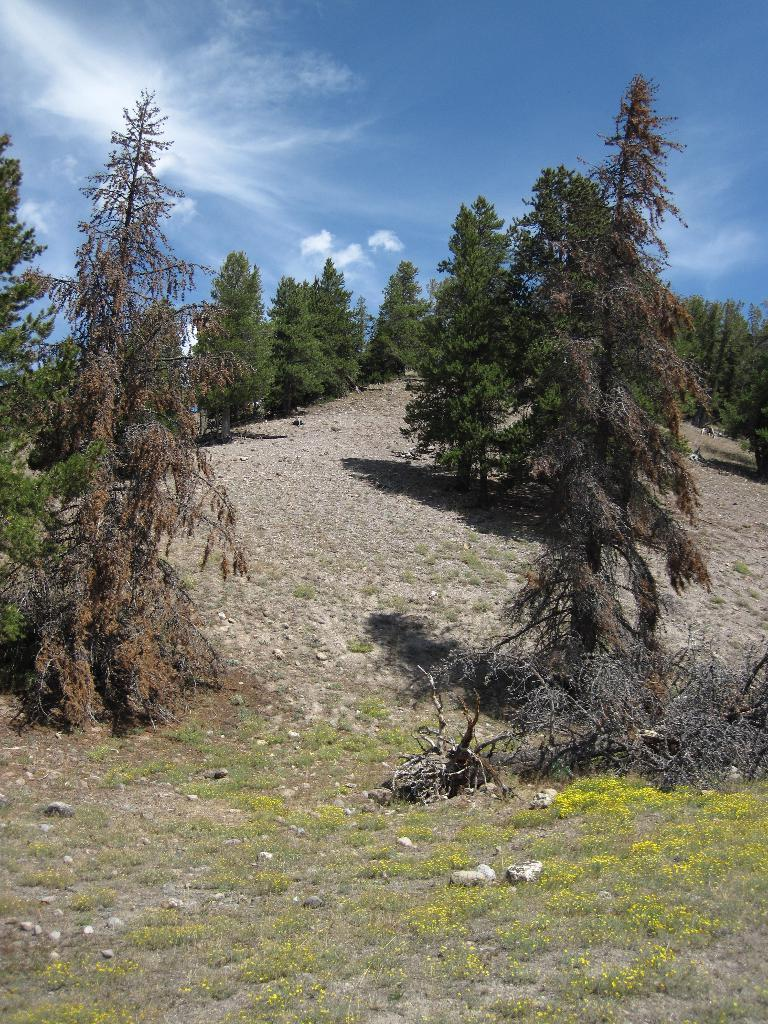What type of vegetation can be seen in the image? There are trees in the image. What is on the ground in the image? There is grass on the ground in the image. What other elements can be found on the ground in the image? There are small stones in the image. What is visible in the background of the image? There is a sky visible in the background of the image. What can be seen in the sky in the background of the image? There are clouds in the sky in the background of the image. What type of jewel is hanging from the tree in the image? There is no jewel hanging from the tree in the image; it only features trees, grass, small stones, sand, and a sky with clouds. What book is the person reading in the image? There is no person reading a book in the image; it does not depict any reading activity. 